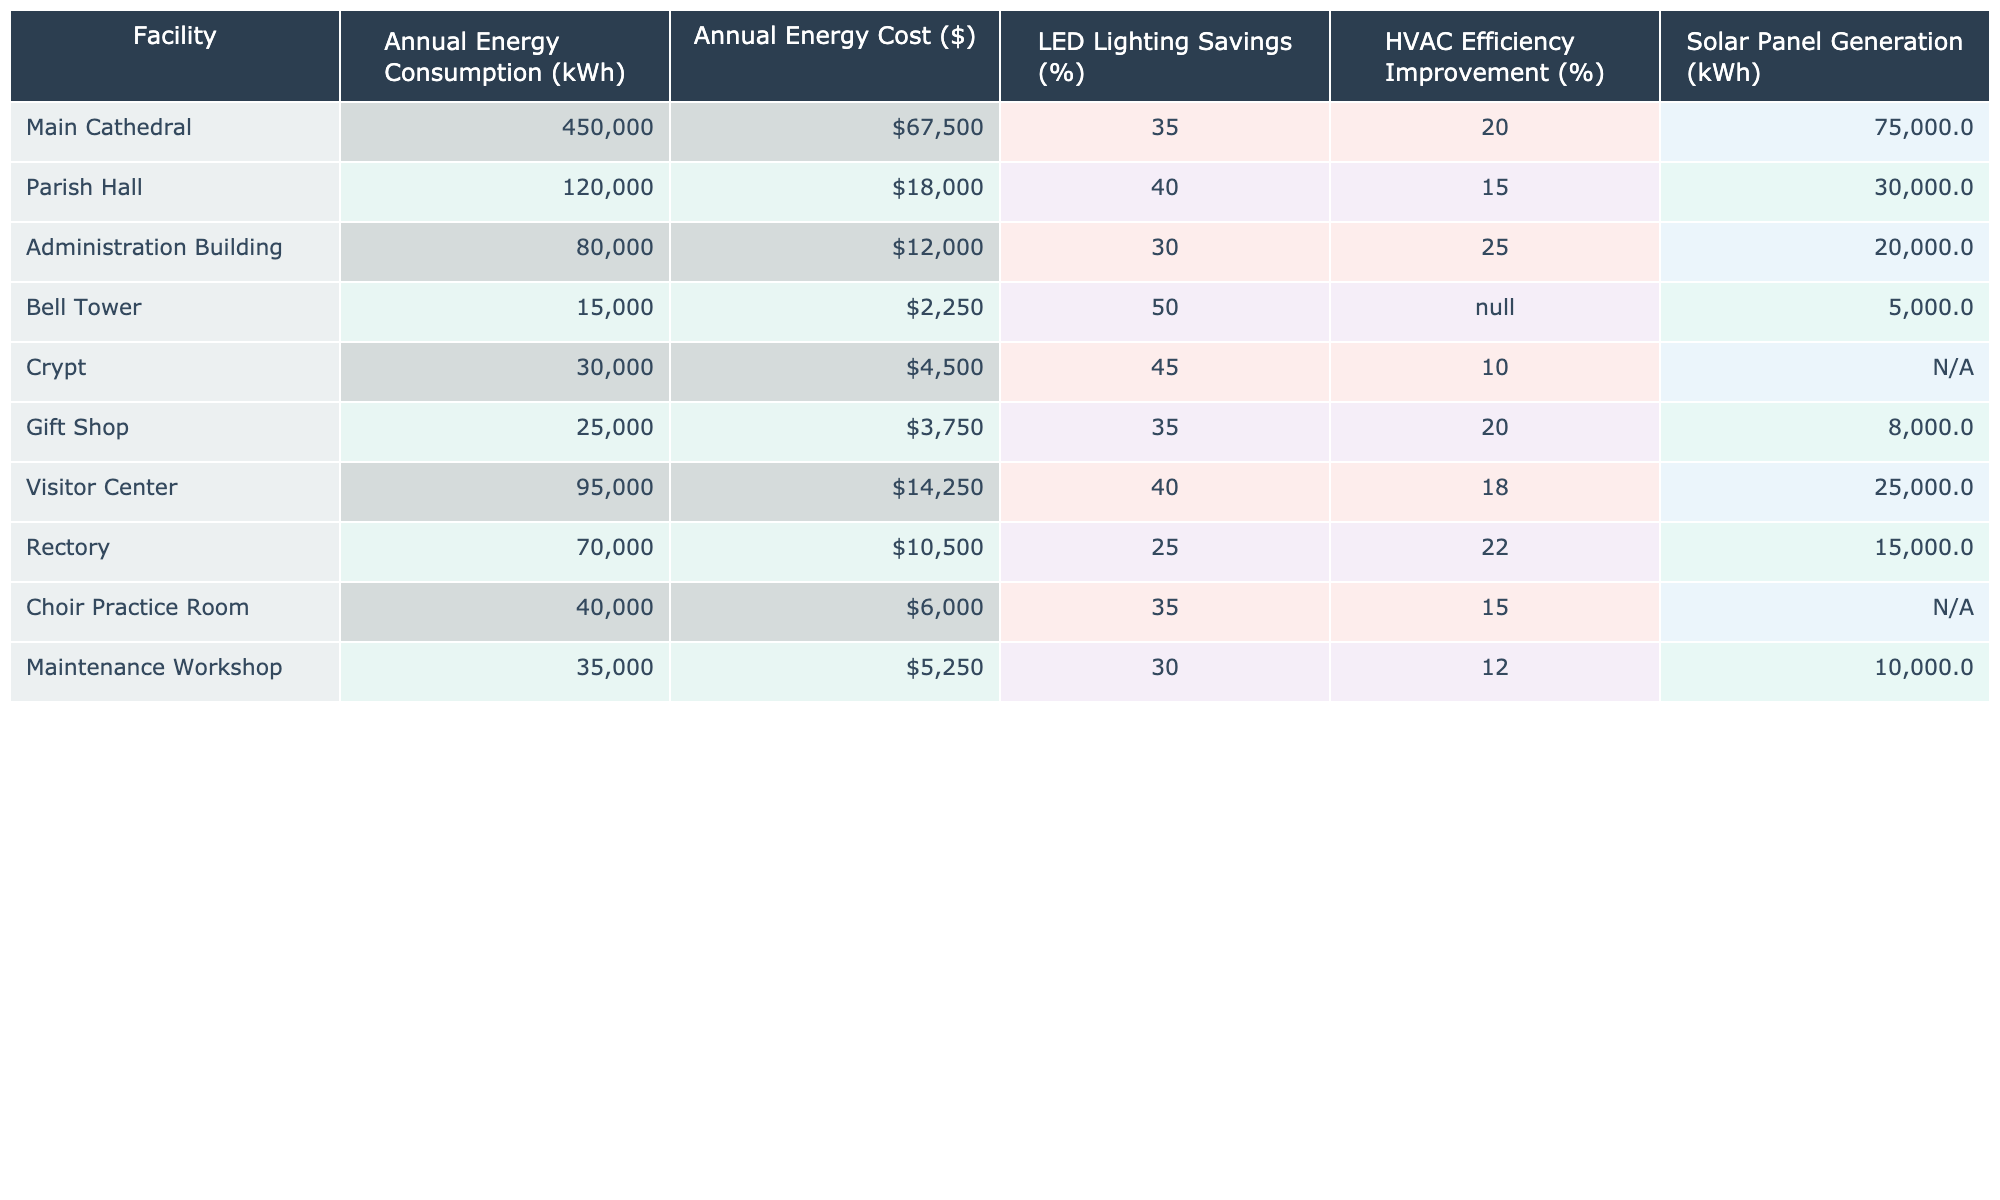What is the annual energy consumption of the Main Cathedral? Referring to the table, the Main Cathedral's annual energy consumption is explicitly noted under the relevant column. The value is 450,000 kWh.
Answer: 450,000 kWh Which facility has the highest annual energy cost? By examining the annual energy cost column, we can identify that the Main Cathedral has the highest value at $67,500.
Answer: Main Cathedral What percentage savings in LED lighting does the Visitor Center have compared to the Rectory? The LED lighting savings for the Visitor Center is 40% and for the Rectory it is 25%. The difference between them is 40% - 25% = 15%.
Answer: 15% How much energy is generated from solar panels by the Administration Building? The Administration Building's solar panel generation is listed in the table, which shows a value of 20,000 kWh.
Answer: 20,000 kWh Is the HVAC efficiency improvement for the Bell Tower available? The table indicates that the HVAC efficiency improvement for the Bell Tower is marked as N/A, hence no value is provided.
Answer: No What is the total annual energy consumption of all facilities combined? To get this value, we sum the annual energy consumption figures for each facility: 450,000 + 120,000 + 80,000 + 15,000 + 30,000 + 25,000 + 95,000 + 70,000 + 40,000 + 35,000 = 915,000 kWh.
Answer: 915,000 kWh Do any of the facilities have solar panel generation listed as 'N/A'? Yes, both the Crypt and the Bell Tower have 'N/A' under the solar panel generation column, indicating no data.
Answer: Yes What is the average annual energy cost across all listed facilities? The annual energy costs are $67,500, $18,000, $12,000, $2,250, $4,500, $3,750, $14,250, $10,500, $6,000, $5,250. There are 10 facilities, so the average is (67,500 + 18,000 + 12,000 + 2,250 + 4,500 + 3,750 + 14,250 + 10,500 + 6,000 + 5,250) / 10 = $16,250.
Answer: $16,250 Which facility shows the greatest percentage improvement in HVAC efficiency? The facilities showing HVAC efficiency improvements are: Main Cathedral (20%), Parish Hall (15%), Administration Building (25%), Rectory (22%), Choir Practice Room (15%), and Maintenance Workshop (12%). The Administration Building has the highest improvement at 25%.
Answer: Administration Building If the energy savings from LED lighting is applied to the Visitor Center, how much would the annual cost decrease? To find this, we multiply the Visitor Center's consumption by its LED savings percentage: 95,000 kWh * 0.40 = 38,000 kWh saved. The monetary value saved would be 38,000 kWh * ($142.5 / 1000) = $5,405.25.
Answer: $5,405.25 